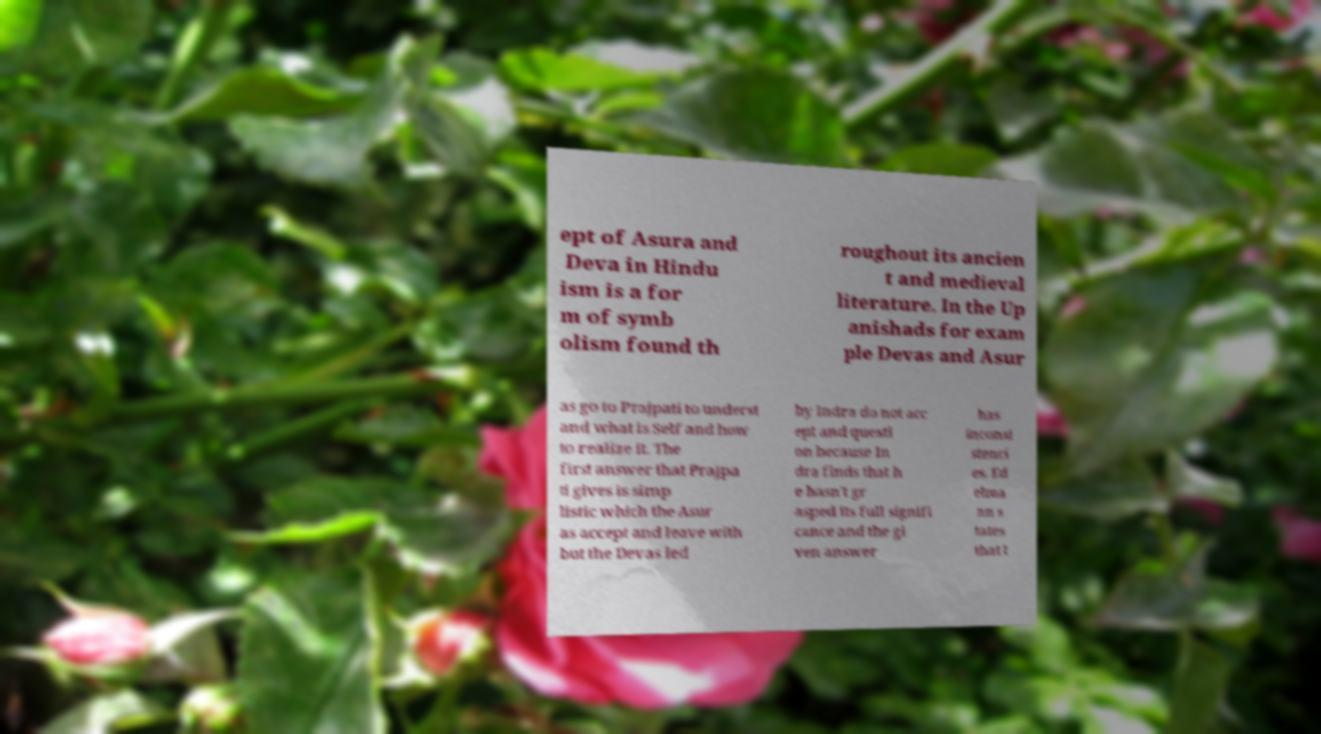Please identify and transcribe the text found in this image. ept of Asura and Deva in Hindu ism is a for m of symb olism found th roughout its ancien t and medieval literature. In the Up anishads for exam ple Devas and Asur as go to Prajpati to underst and what is Self and how to realize it. The first answer that Prajpa ti gives is simp listic which the Asur as accept and leave with but the Devas led by Indra do not acc ept and questi on because In dra finds that h e hasn't gr asped its full signifi cance and the gi ven answer has inconsi stenci es. Ed elma nn s tates that t 